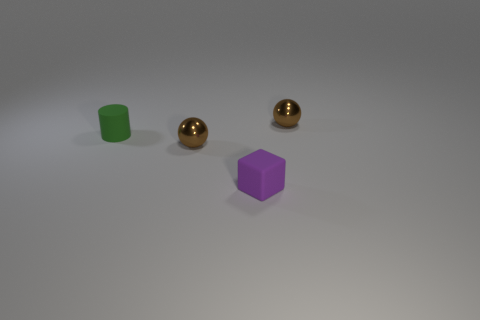Do the tiny brown thing in front of the small cylinder and the tiny green cylinder left of the tiny purple thing have the same material?
Keep it short and to the point. No. What number of tiny objects are there?
Offer a terse response. 4. What is the shape of the green rubber object behind the tiny purple matte cube?
Keep it short and to the point. Cylinder. What number of other objects are the same size as the cylinder?
Your response must be concise. 3. Is the shape of the small brown object that is on the left side of the purple block the same as the tiny brown metallic thing behind the matte cylinder?
Give a very brief answer. Yes. How many spheres are to the right of the small purple rubber thing?
Give a very brief answer. 1. The tiny matte thing in front of the green cylinder is what color?
Offer a very short reply. Purple. Is the number of tiny matte cubes greater than the number of small green matte balls?
Keep it short and to the point. Yes. Is the green cylinder made of the same material as the small cube?
Offer a terse response. Yes. How many red blocks are made of the same material as the cylinder?
Your answer should be very brief. 0. 